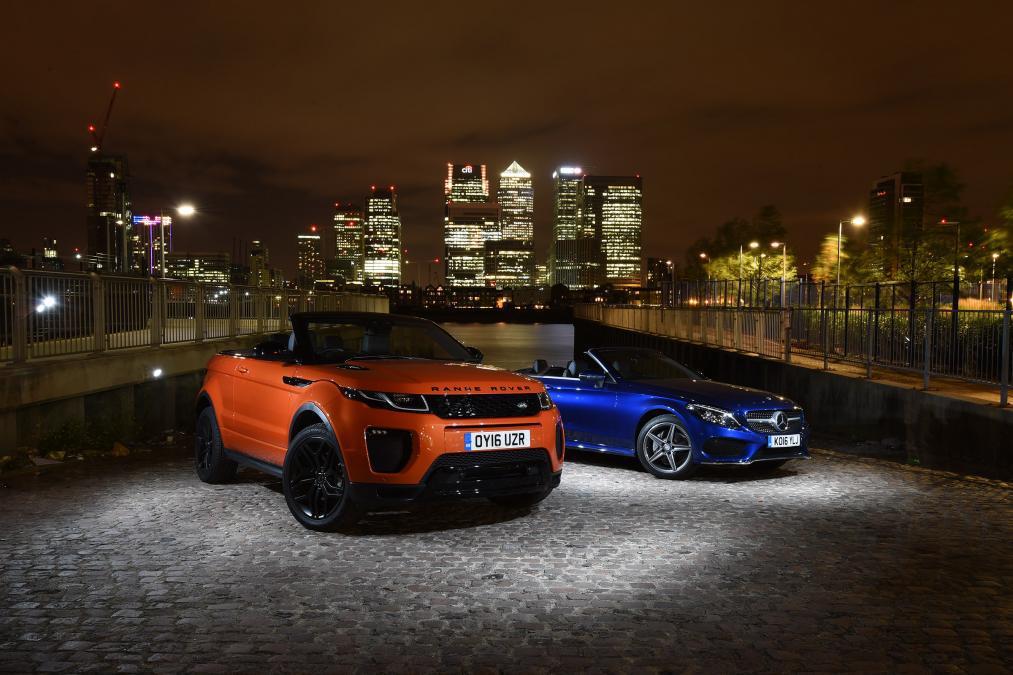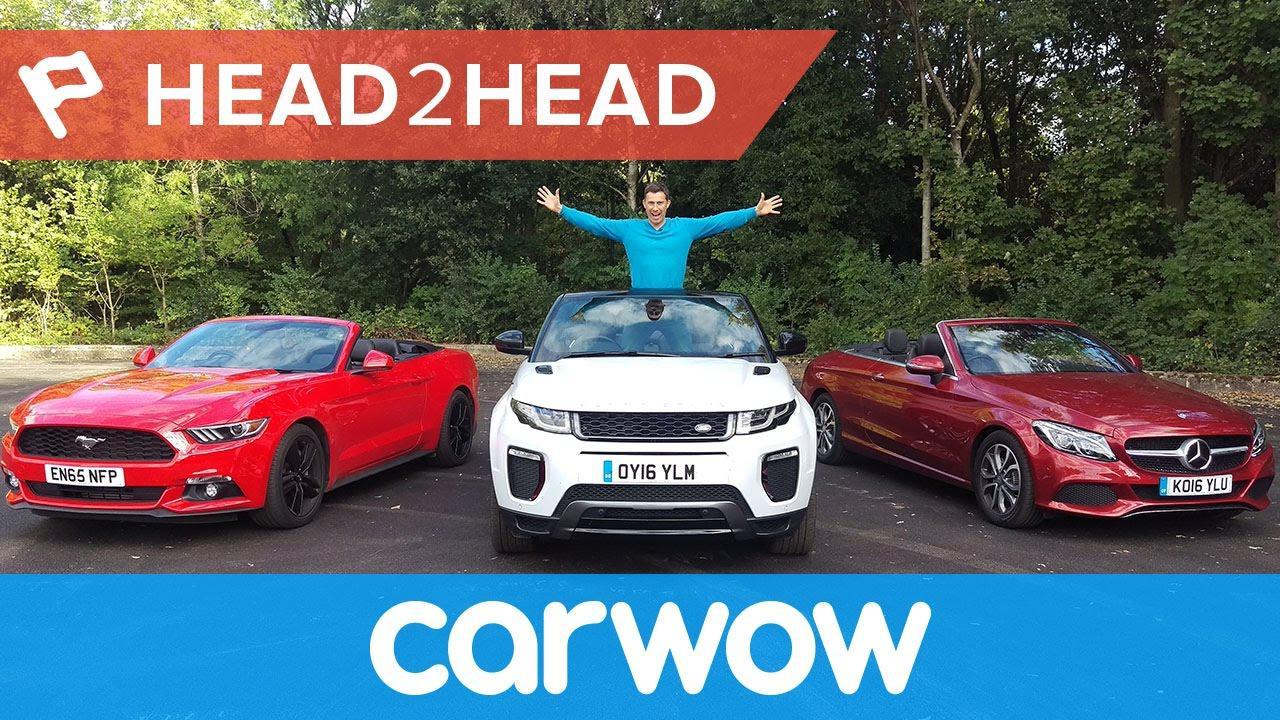The first image is the image on the left, the second image is the image on the right. Analyze the images presented: Is the assertion "There are two cars being driven on roads." valid? Answer yes or no. No. The first image is the image on the left, the second image is the image on the right. Evaluate the accuracy of this statement regarding the images: "The left image contains two cars including one blue one, and the right image includes a dark red convertible with its top down.". Is it true? Answer yes or no. Yes. 